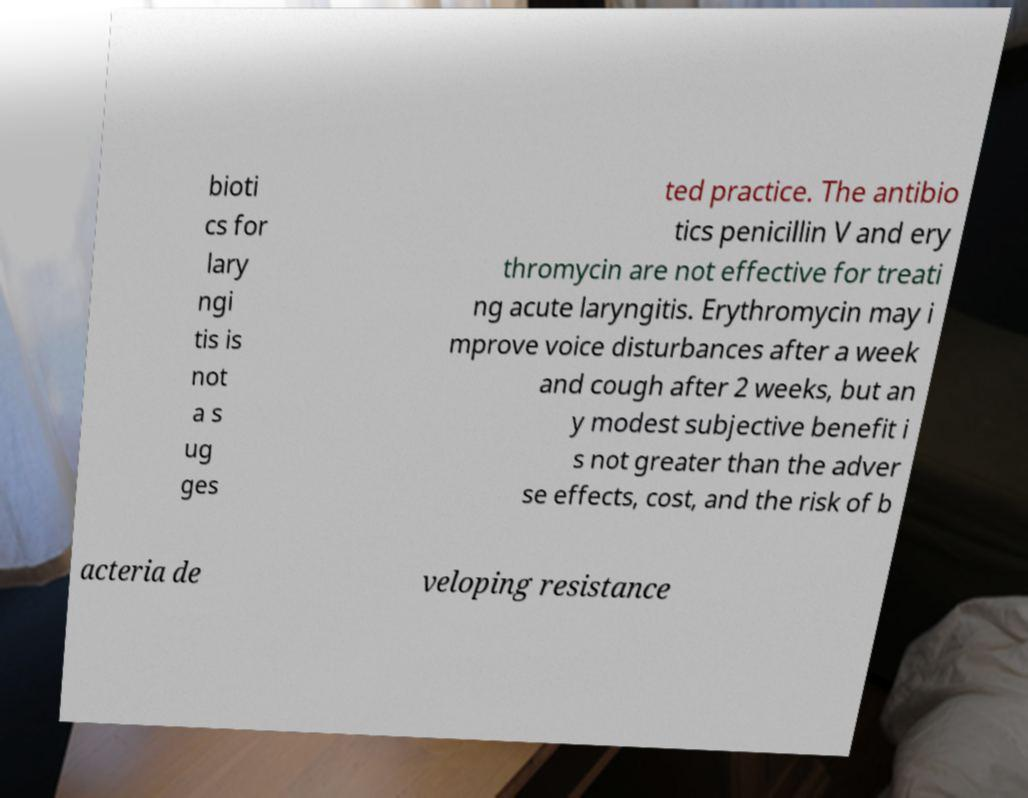Could you extract and type out the text from this image? bioti cs for lary ngi tis is not a s ug ges ted practice. The antibio tics penicillin V and ery thromycin are not effective for treati ng acute laryngitis. Erythromycin may i mprove voice disturbances after a week and cough after 2 weeks, but an y modest subjective benefit i s not greater than the adver se effects, cost, and the risk of b acteria de veloping resistance 